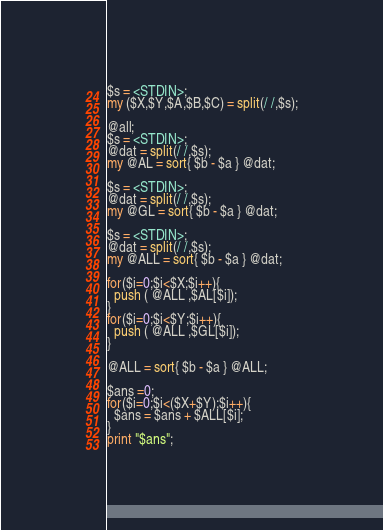<code> <loc_0><loc_0><loc_500><loc_500><_Perl_>$s = <STDIN>;
my ($X,$Y,$A,$B,$C) = split(/ /,$s);

@all;
$s = <STDIN>;
@dat = split(/ /,$s);
my @AL = sort{ $b - $a } @dat;

$s = <STDIN>;
@dat = split(/ /,$s);
my @GL = sort{ $b - $a } @dat;

$s = <STDIN>;
@dat = split(/ /,$s);
my @ALL = sort{ $b - $a } @dat;

for($i=0;$i<$X;$i++){
  push ( @ALL ,$AL[$i]);
}
for($i=0;$i<$Y;$i++){
  push ( @ALL ,$GL[$i]);
}

@ALL = sort{ $b - $a } @ALL;

$ans =0;
for($i=0;$i<($X+$Y);$i++){
  $ans = $ans + $ALL[$i];
}
print "$ans";</code> 